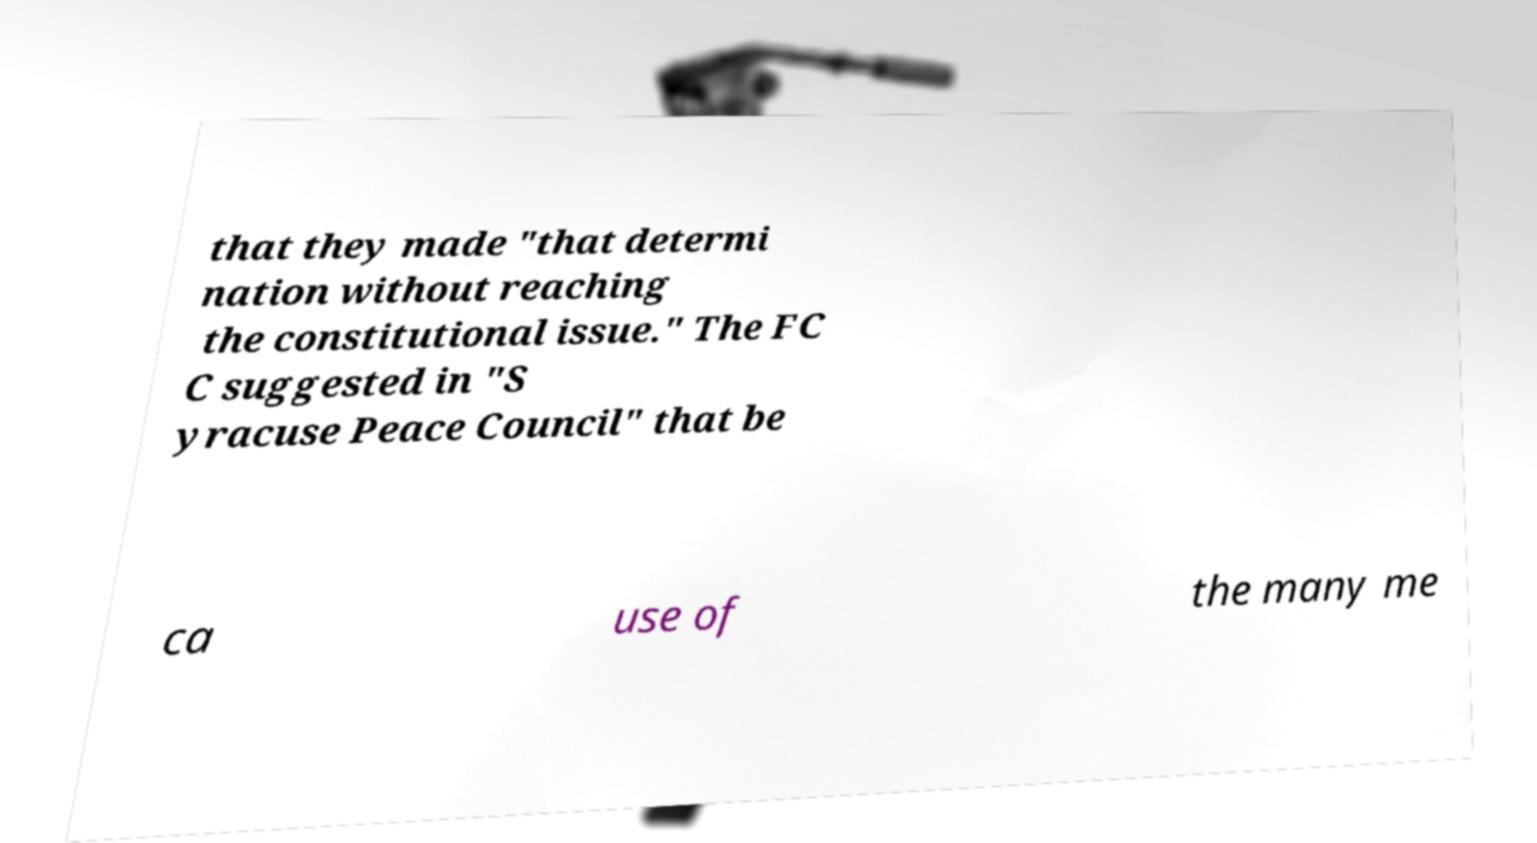What messages or text are displayed in this image? I need them in a readable, typed format. that they made "that determi nation without reaching the constitutional issue." The FC C suggested in "S yracuse Peace Council" that be ca use of the many me 